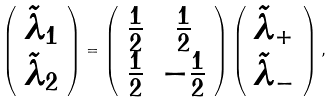<formula> <loc_0><loc_0><loc_500><loc_500>\left ( \begin{array} { c } \tilde { \lambda } _ { 1 } \\ \tilde { \lambda } _ { 2 } \end{array} \right ) = \left ( \begin{array} { c c } \frac { 1 } { 2 } & \frac { 1 } { 2 } \\ \frac { 1 } { 2 } & - \frac { 1 } { 2 } \end{array} \right ) \left ( \begin{array} { c } \tilde { \lambda } _ { + } \\ \tilde { \lambda } _ { - } \end{array} \right ) ,</formula> 